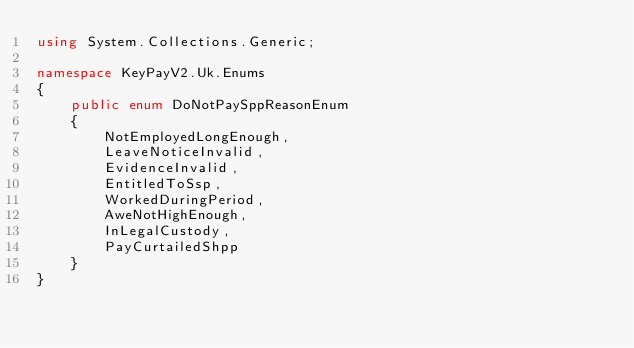<code> <loc_0><loc_0><loc_500><loc_500><_C#_>using System.Collections.Generic;

namespace KeyPayV2.Uk.Enums
{
    public enum DoNotPaySppReasonEnum
    {
        NotEmployedLongEnough,
        LeaveNoticeInvalid,
        EvidenceInvalid,
        EntitledToSsp,
        WorkedDuringPeriod,
        AweNotHighEnough,
        InLegalCustody,
        PayCurtailedShpp
    }
}
</code> 